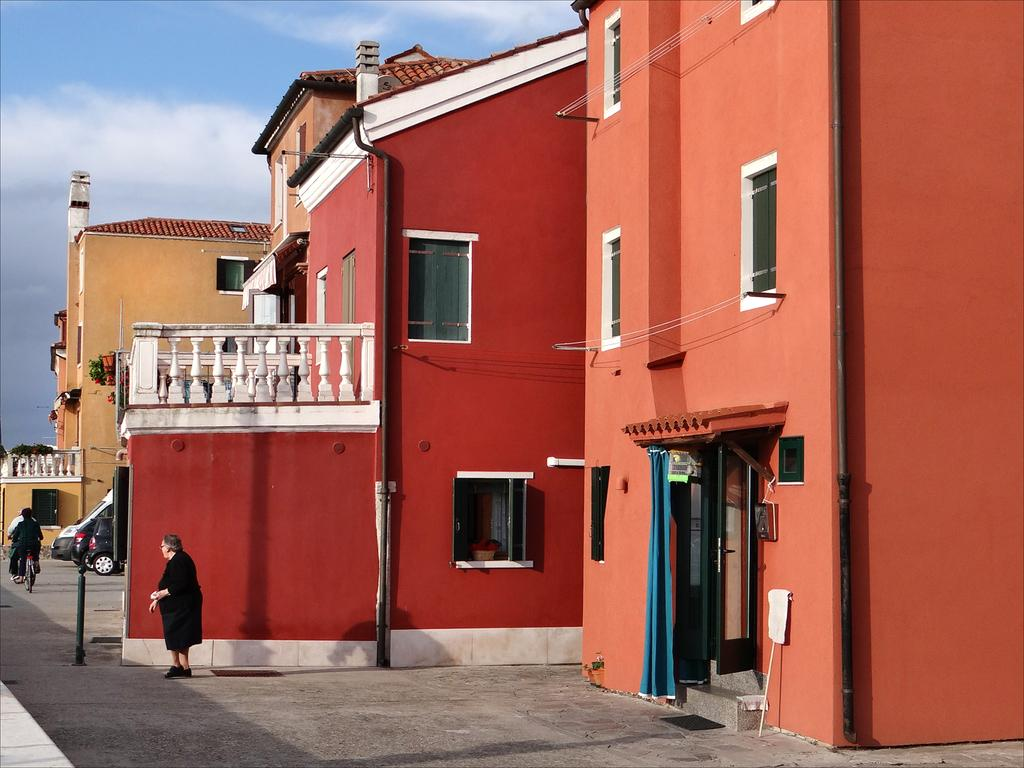What type of structures can be seen in the image? There are buildings with windows in the image. What other elements are present in the image besides buildings? There are plants, people, vehicles, doors, and curtains visible in the image. What can be seen in the background of the image? The sky is visible in the background of the image. What type of rice is being served to the visitor in the image? There is no rice or visitor present in the image. How many times has the earth been visited by aliens in the image? There is no reference to aliens or the earth in the image. 